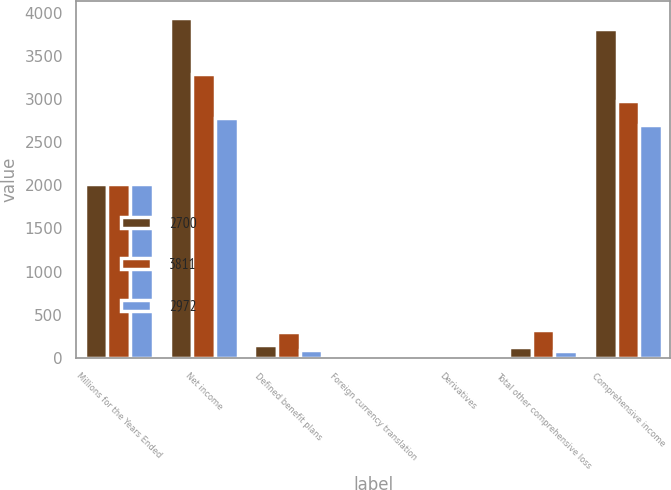<chart> <loc_0><loc_0><loc_500><loc_500><stacked_bar_chart><ecel><fcel>Millions for the Years Ended<fcel>Net income<fcel>Defined benefit plans<fcel>Foreign currency translation<fcel>Derivatives<fcel>Total other comprehensive loss<fcel>Comprehensive income<nl><fcel>2700<fcel>2012<fcel>3943<fcel>145<fcel>12<fcel>1<fcel>132<fcel>3811<nl><fcel>3811<fcel>2011<fcel>3292<fcel>301<fcel>20<fcel>1<fcel>320<fcel>2972<nl><fcel>2972<fcel>2010<fcel>2780<fcel>88<fcel>7<fcel>1<fcel>80<fcel>2700<nl></chart> 